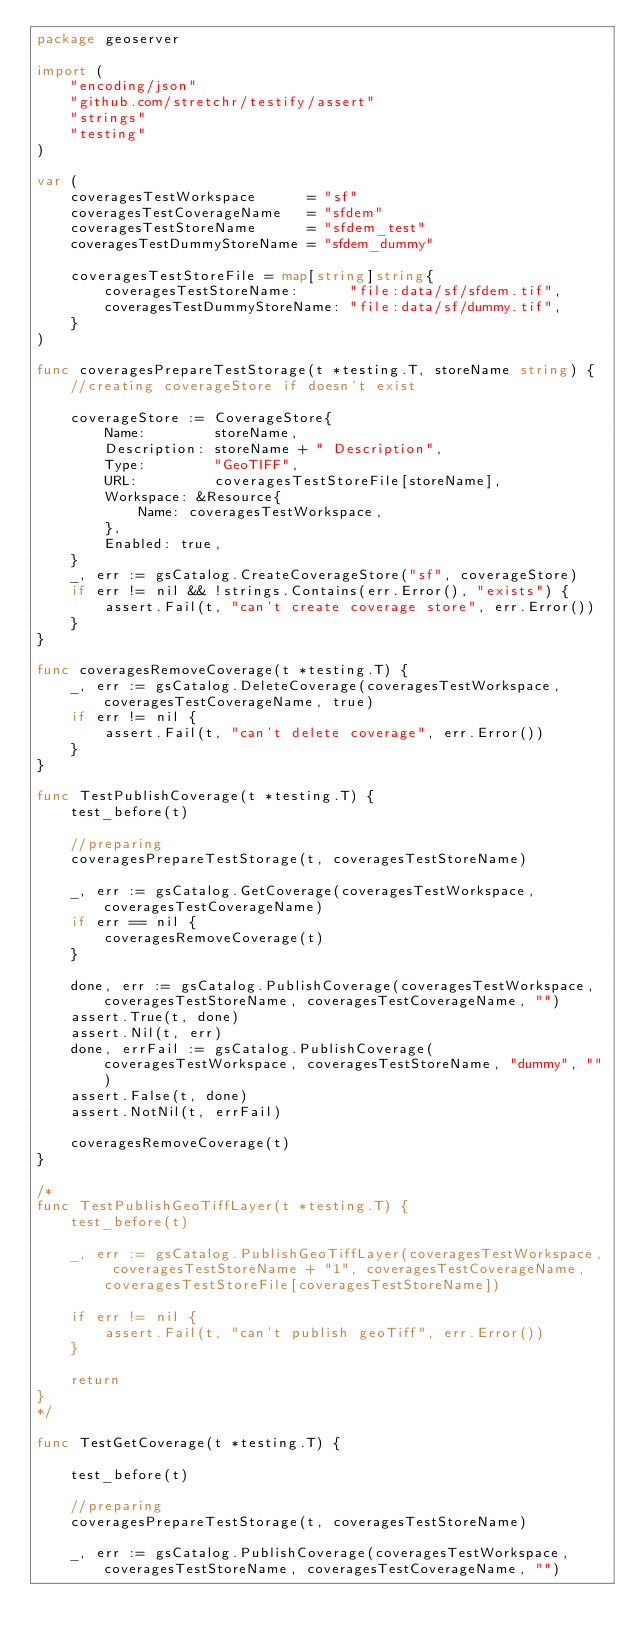<code> <loc_0><loc_0><loc_500><loc_500><_Go_>package geoserver

import (
	"encoding/json"
	"github.com/stretchr/testify/assert"
	"strings"
	"testing"
)

var (
	coveragesTestWorkspace      = "sf"
	coveragesTestCoverageName   = "sfdem"
	coveragesTestStoreName      = "sfdem_test"
	coveragesTestDummyStoreName = "sfdem_dummy"

	coveragesTestStoreFile = map[string]string{
		coveragesTestStoreName:      "file:data/sf/sfdem.tif",
		coveragesTestDummyStoreName: "file:data/sf/dummy.tif",
	}
)

func coveragesPrepareTestStorage(t *testing.T, storeName string) {
	//creating coverageStore if doesn't exist

	coverageStore := CoverageStore{
		Name:        storeName,
		Description: storeName + " Description",
		Type:        "GeoTIFF",
		URL:         coveragesTestStoreFile[storeName],
		Workspace: &Resource{
			Name: coveragesTestWorkspace,
		},
		Enabled: true,
	}
	_, err := gsCatalog.CreateCoverageStore("sf", coverageStore)
	if err != nil && !strings.Contains(err.Error(), "exists") {
		assert.Fail(t, "can't create coverage store", err.Error())
	}
}

func coveragesRemoveCoverage(t *testing.T) {
	_, err := gsCatalog.DeleteCoverage(coveragesTestWorkspace, coveragesTestCoverageName, true)
	if err != nil {
		assert.Fail(t, "can't delete coverage", err.Error())
	}
}

func TestPublishCoverage(t *testing.T) {
	test_before(t)

	//preparing
	coveragesPrepareTestStorage(t, coveragesTestStoreName)

	_, err := gsCatalog.GetCoverage(coveragesTestWorkspace, coveragesTestCoverageName)
	if err == nil {
		coveragesRemoveCoverage(t)
	}

	done, err := gsCatalog.PublishCoverage(coveragesTestWorkspace, coveragesTestStoreName, coveragesTestCoverageName, "")
	assert.True(t, done)
	assert.Nil(t, err)
	done, errFail := gsCatalog.PublishCoverage(coveragesTestWorkspace, coveragesTestStoreName, "dummy", "")
	assert.False(t, done)
	assert.NotNil(t, errFail)

	coveragesRemoveCoverage(t)
}

/*
func TestPublishGeoTiffLayer(t *testing.T) {
	test_before(t)

	_, err := gsCatalog.PublishGeoTiffLayer(coveragesTestWorkspace, coveragesTestStoreName + "1", coveragesTestCoverageName, coveragesTestStoreFile[coveragesTestStoreName])

	if err != nil {
		assert.Fail(t, "can't publish geoTiff", err.Error())
	}

	return
}
*/

func TestGetCoverage(t *testing.T) {

	test_before(t)

	//preparing
	coveragesPrepareTestStorage(t, coveragesTestStoreName)

	_, err := gsCatalog.PublishCoverage(coveragesTestWorkspace, coveragesTestStoreName, coveragesTestCoverageName, "")</code> 